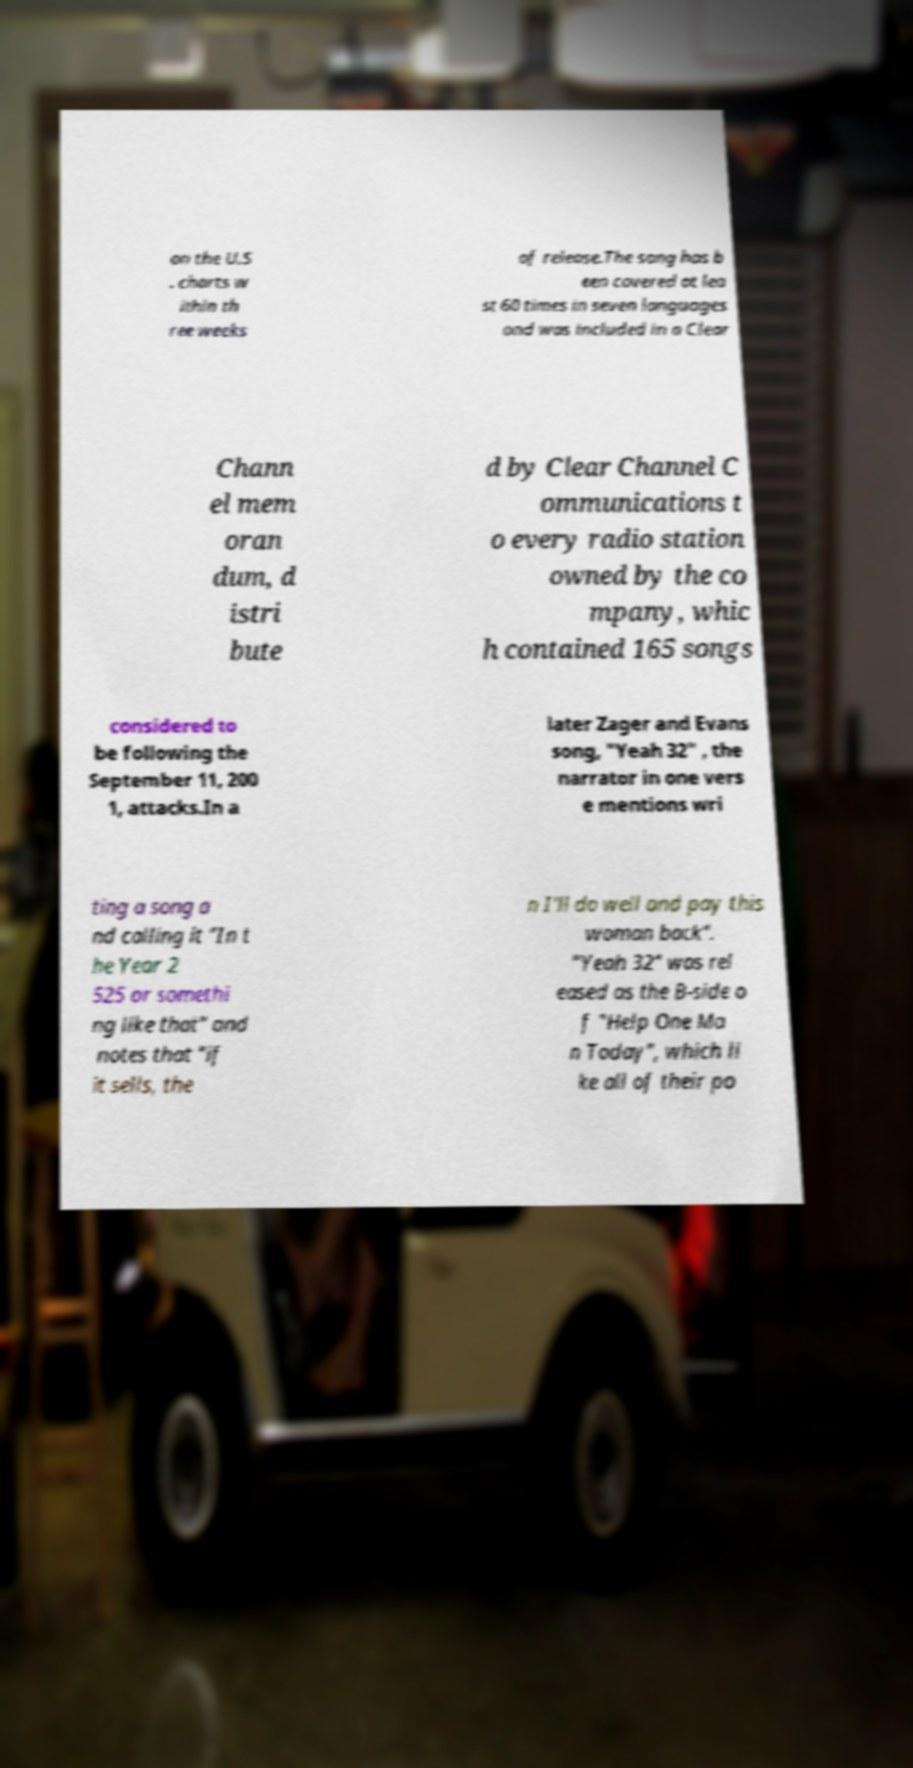Could you extract and type out the text from this image? on the U.S . charts w ithin th ree weeks of release.The song has b een covered at lea st 60 times in seven languages and was included in a Clear Chann el mem oran dum, d istri bute d by Clear Channel C ommunications t o every radio station owned by the co mpany, whic h contained 165 songs considered to be following the September 11, 200 1, attacks.In a later Zager and Evans song, "Yeah 32" , the narrator in one vers e mentions wri ting a song a nd calling it "In t he Year 2 525 or somethi ng like that" and notes that "if it sells, the n I'll do well and pay this woman back". "Yeah 32" was rel eased as the B-side o f "Help One Ma n Today", which li ke all of their po 